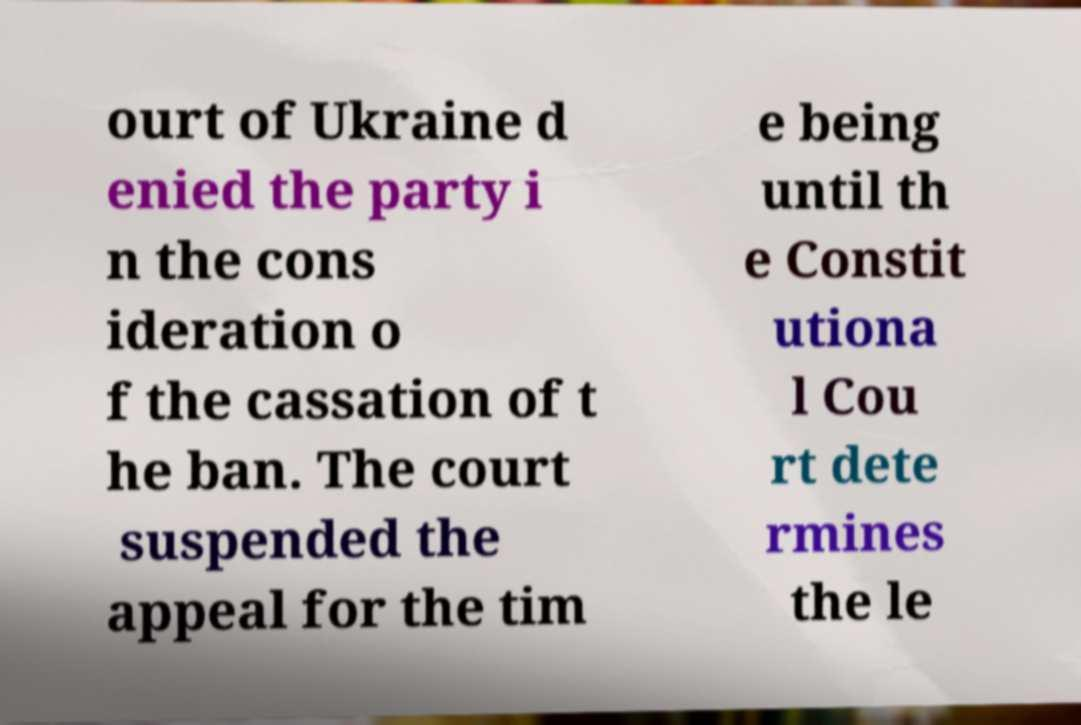Please identify and transcribe the text found in this image. ourt of Ukraine d enied the party i n the cons ideration o f the cassation of t he ban. The court suspended the appeal for the tim e being until th e Constit utiona l Cou rt dete rmines the le 